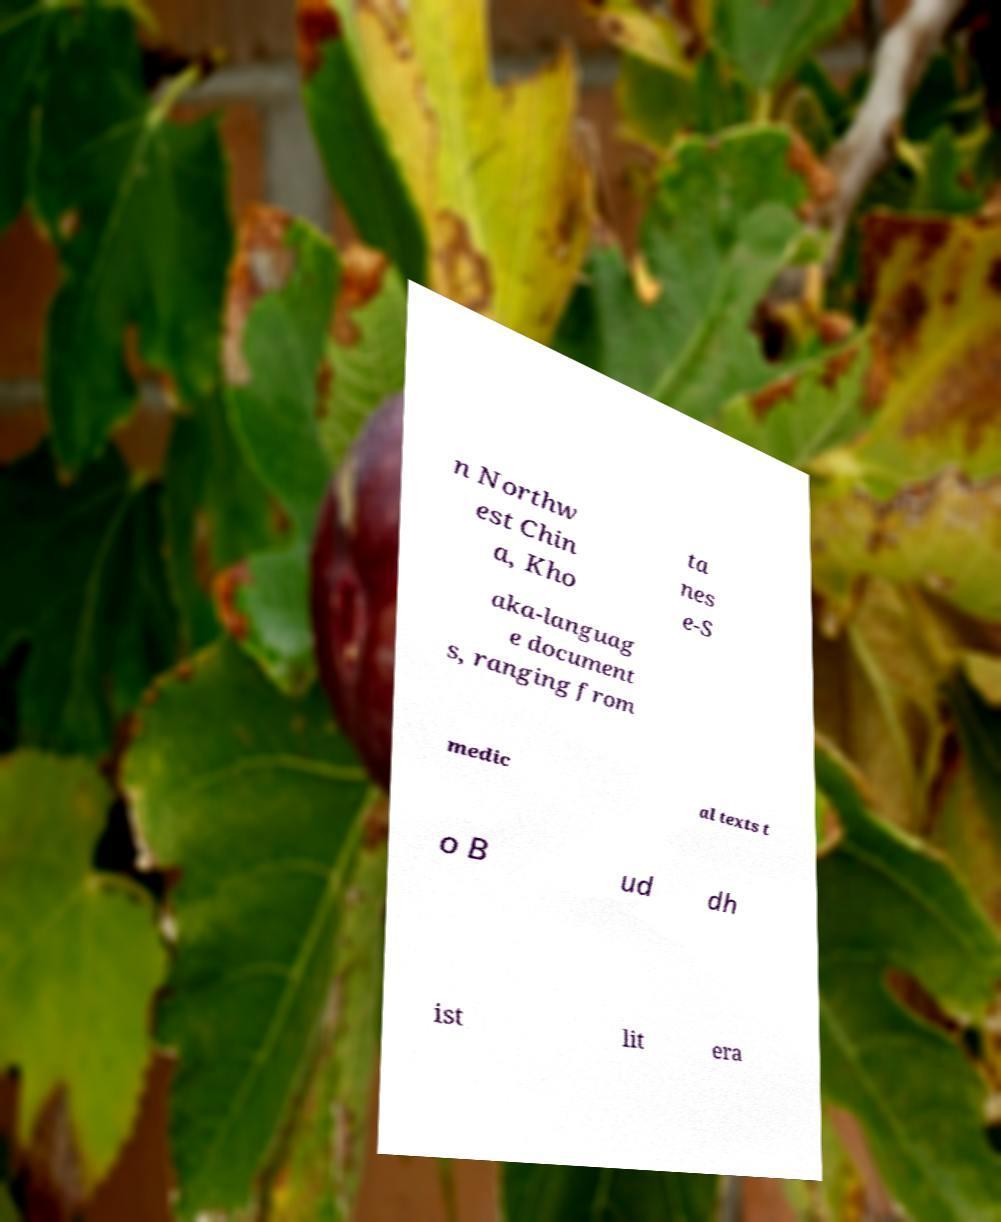Could you assist in decoding the text presented in this image and type it out clearly? n Northw est Chin a, Kho ta nes e-S aka-languag e document s, ranging from medic al texts t o B ud dh ist lit era 